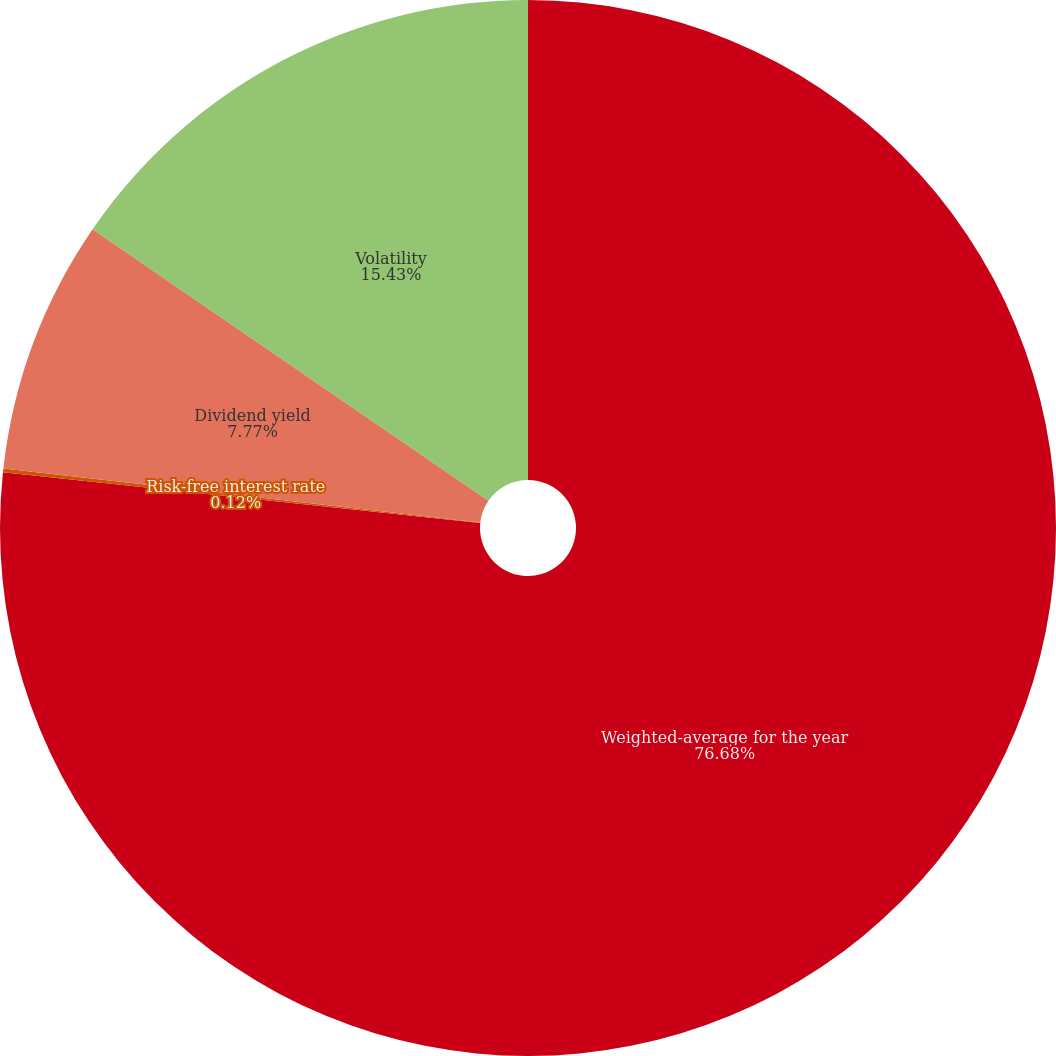<chart> <loc_0><loc_0><loc_500><loc_500><pie_chart><fcel>Weighted-average for the year<fcel>Risk-free interest rate<fcel>Dividend yield<fcel>Volatility<nl><fcel>76.68%<fcel>0.12%<fcel>7.77%<fcel>15.43%<nl></chart> 